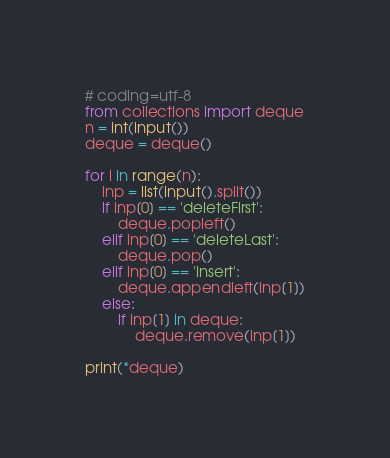<code> <loc_0><loc_0><loc_500><loc_500><_Python_># coding=utf-8
from collections import deque
n = int(input())
deque = deque()

for i in range(n):
    inp = list(input().split())
    if inp[0] == 'deleteFirst':
        deque.popleft()
    elif inp[0] == 'deleteLast':
        deque.pop()
    elif inp[0] == 'insert':
        deque.appendleft(inp[1])
    else:
        if inp[1] in deque:
            deque.remove(inp[1])

print(*deque)</code> 